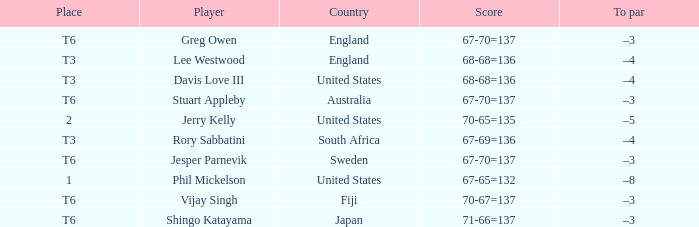Name the player for fiji Vijay Singh. 